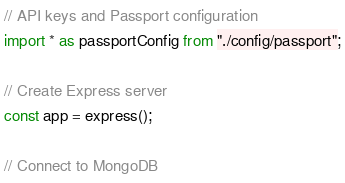Convert code to text. <code><loc_0><loc_0><loc_500><loc_500><_TypeScript_>
// API keys and Passport configuration
import * as passportConfig from "./config/passport";

// Create Express server
const app = express();

// Connect to MongoDB</code> 